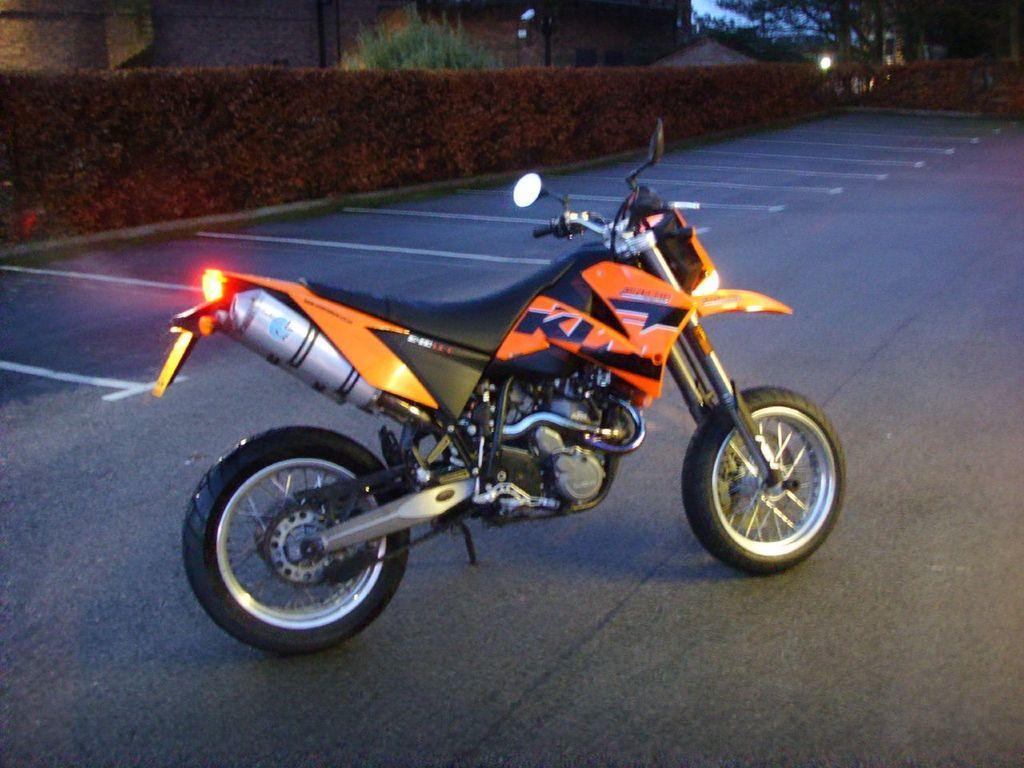Describe this image in one or two sentences. In this image there is a bike parked on the road in middle of this image and there are some plants in the background and there is a building at top of this image. 